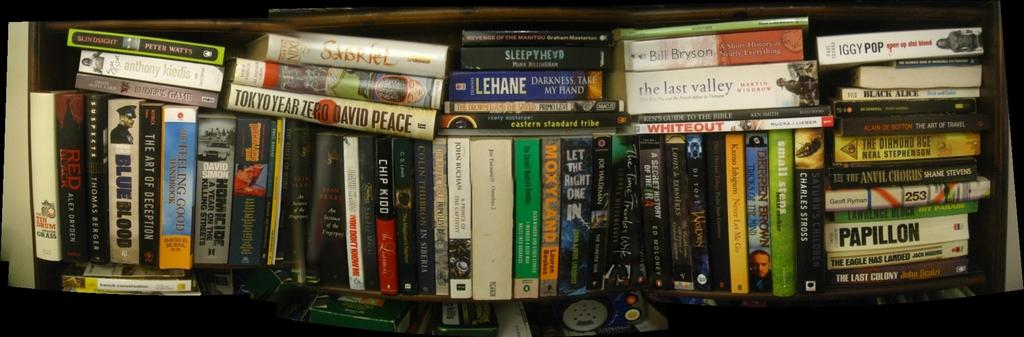Provide a one-sentence caption for the provided image. a book that says Papillon among many other books. 